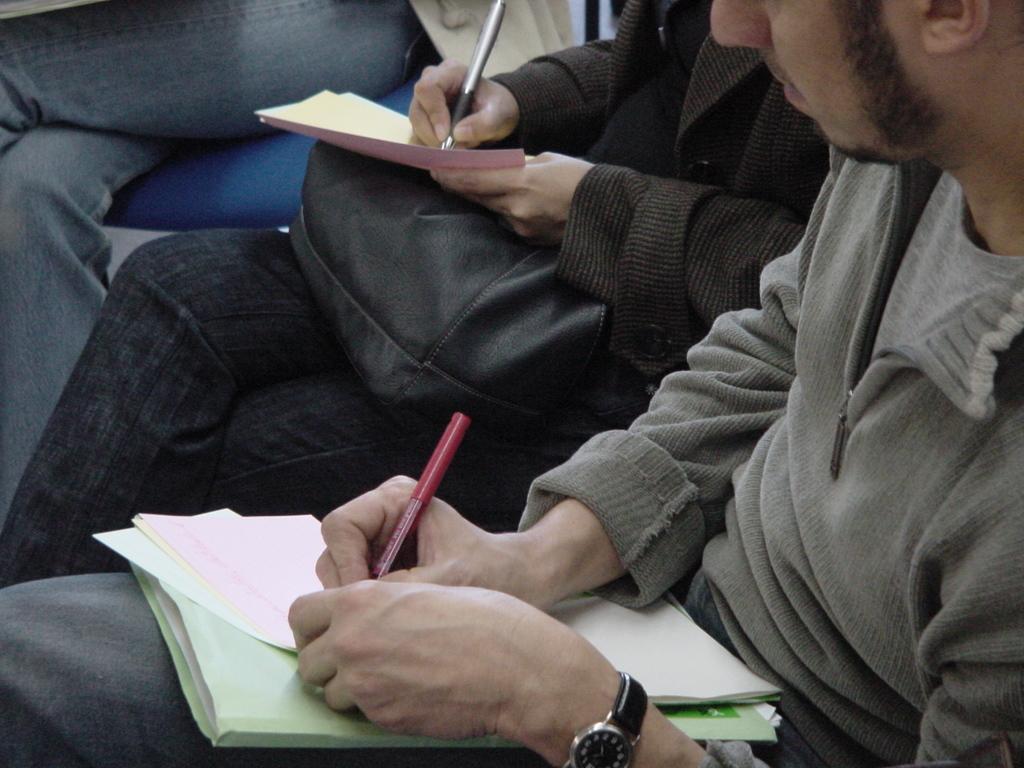Describe this image in one or two sentences. This image consists of a man writing on a paper. Beside him there is a woman holding a black color bag. He is also wearing a watch. 